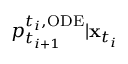<formula> <loc_0><loc_0><loc_500><loc_500>p _ { t _ { i + 1 } } ^ { t _ { i } , O D E } | x _ { t _ { i } }</formula> 